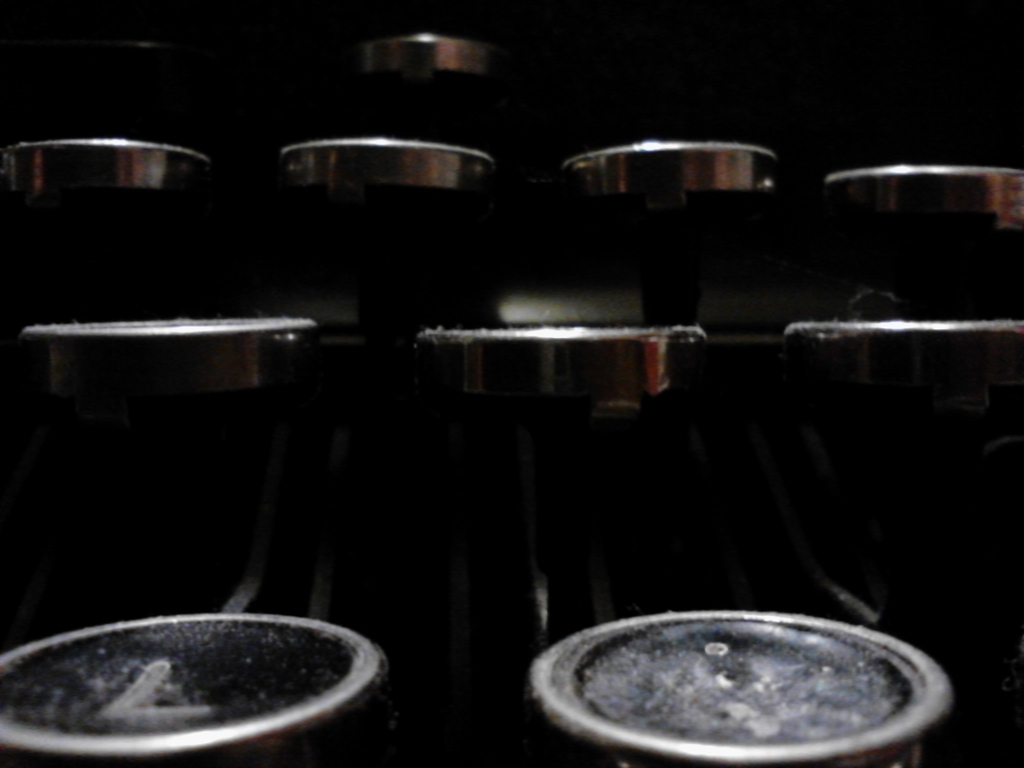Is this image mostly composed of black?
A. Yes
B. No
Answer with the option's letter from the given choices directly. While the background of the image is predominantly dark, which may give the initial impression that the answer should be 'A', a closer inspection reveals that the objects in the foreground are metallic with reflections and highlights. This complex interplay of light and shadow means that a simplistic classification of the entire image as 'mostly black' is not accurate. Therefore, a more nuanced answer would be 'B', the image is not mostly composed of black but has significant portions of metallic or reflective surfaces which are not black. 